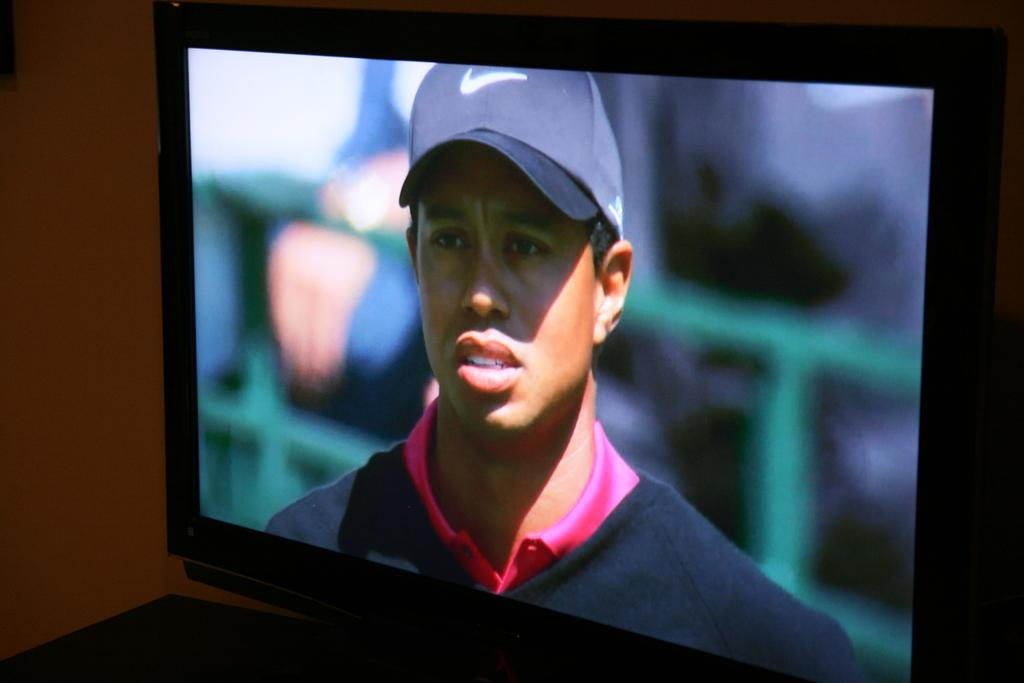What is the main object in the image? There is a screen in the image. What can be seen on the screen? There is a man on the screen. What is the man wearing on his head? The man is wearing a cap. What is the limit of the baseball field in the image? There is no baseball field present in the image, so it is not possible to determine the limit of a baseball field. 